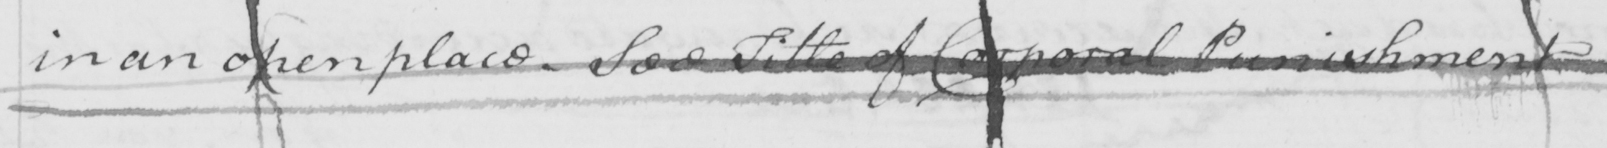Transcribe the text shown in this historical manuscript line. in an open place . See Title of Corporal Punishment  _ 